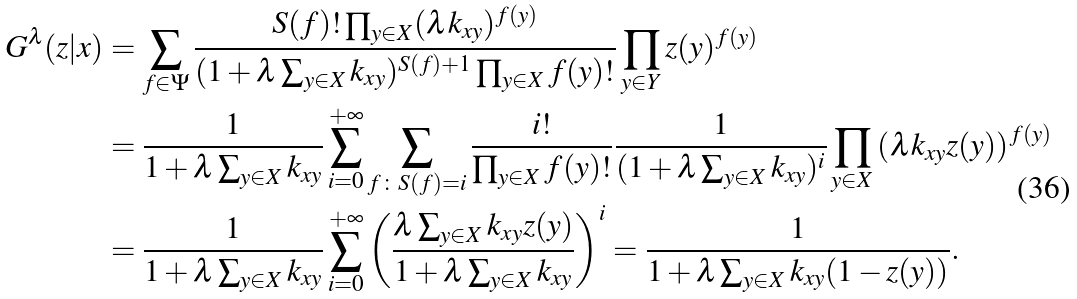Convert formula to latex. <formula><loc_0><loc_0><loc_500><loc_500>G ^ { \lambda } ( z | x ) & = \sum _ { f \in \Psi } \frac { S ( f ) ! \prod _ { y \in X } ( \lambda k _ { x y } ) ^ { f ( y ) } } { ( 1 + \lambda \sum _ { y \in X } k _ { x y } ) ^ { S ( f ) + 1 } \prod _ { y \in X } f ( y ) ! } \prod _ { y \in Y } z ( y ) ^ { f ( y ) } \\ & = \frac { 1 } { 1 + \lambda \sum _ { y \in X } k _ { x y } } \sum _ { i = 0 } ^ { + \infty } \sum _ { f \colon S ( f ) = i } \frac { i ! } { \prod _ { y \in X } f ( y ) ! } \frac { 1 } { ( 1 + \lambda \sum _ { y \in X } k _ { x y } ) ^ { i } } \prod _ { y \in X } \left ( \lambda k _ { x y } z ( y ) \right ) ^ { f ( y ) } \\ & = \frac { 1 } { 1 + \lambda \sum _ { y \in X } k _ { x y } } \sum _ { i = 0 } ^ { + \infty } \left ( \frac { \lambda \sum _ { y \in X } k _ { x y } z ( y ) } { 1 + \lambda \sum _ { y \in X } k _ { x y } } \right ) ^ { i } = \frac { 1 } { 1 + \lambda \sum _ { y \in X } k _ { x y } ( 1 - z ( y ) ) } .</formula> 